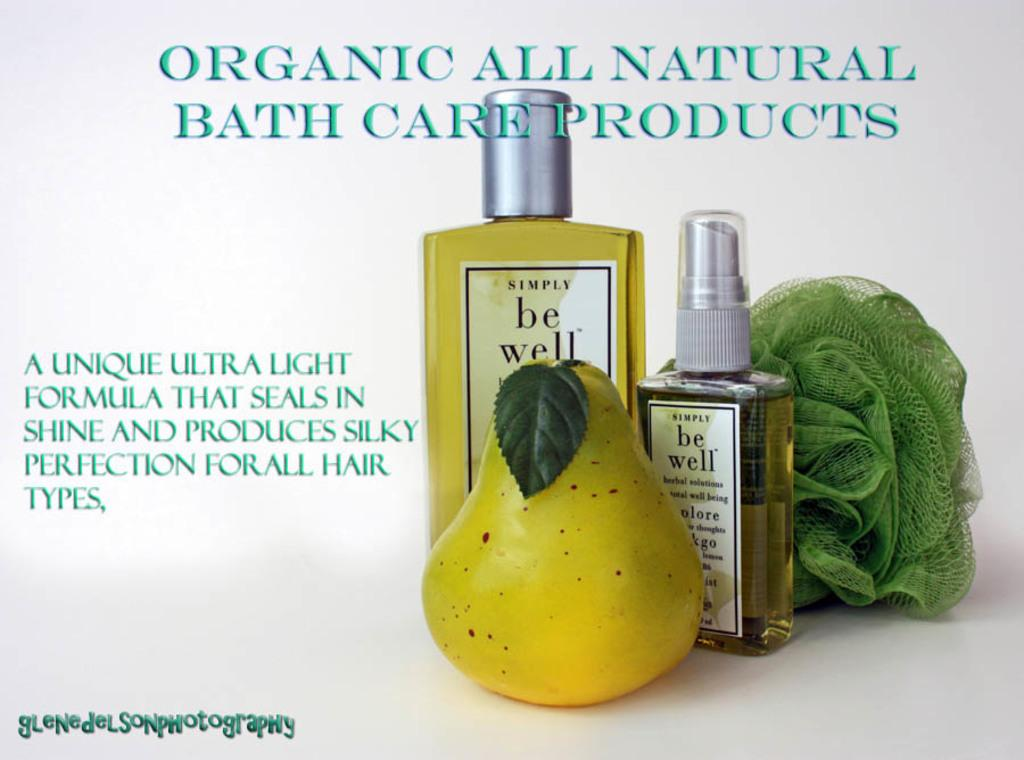<image>
Summarize the visual content of the image. an ad for Organic All Natural Bath Care Products 